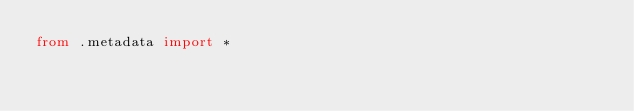<code> <loc_0><loc_0><loc_500><loc_500><_Python_>from .metadata import *
</code> 